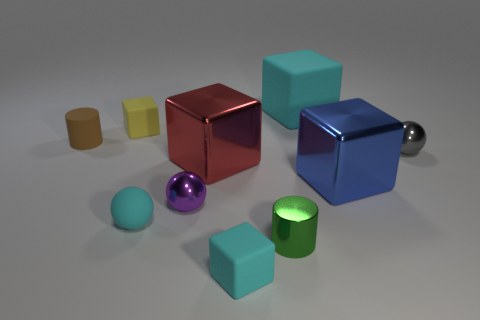What could be the possible uses for these objects in a real-world scenario? These objects can serve various purposes, such as being part of a children's block puzzle, tools for a color-related educational activity, or aesthetically pleasing desktop decorations for organizing office supplies. Can you describe any educational activity in more detail? Certainly! An educational activity could involve matching the objects by color or shape, stacking the cubes to improve motor skills, or using the spheres and cubes in counting exercises to enhance numerical understanding in young children. 